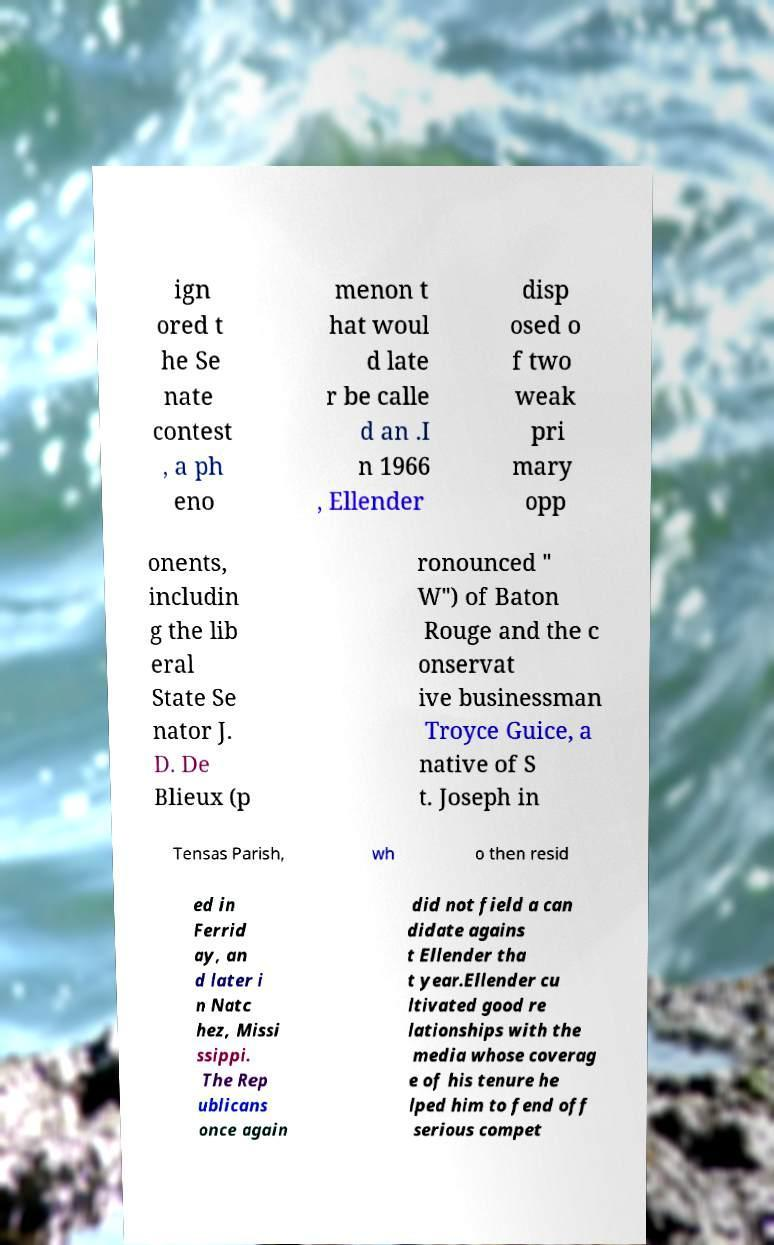What messages or text are displayed in this image? I need them in a readable, typed format. ign ored t he Se nate contest , a ph eno menon t hat woul d late r be calle d an .I n 1966 , Ellender disp osed o f two weak pri mary opp onents, includin g the lib eral State Se nator J. D. De Blieux (p ronounced " W") of Baton Rouge and the c onservat ive businessman Troyce Guice, a native of S t. Joseph in Tensas Parish, wh o then resid ed in Ferrid ay, an d later i n Natc hez, Missi ssippi. The Rep ublicans once again did not field a can didate agains t Ellender tha t year.Ellender cu ltivated good re lationships with the media whose coverag e of his tenure he lped him to fend off serious compet 